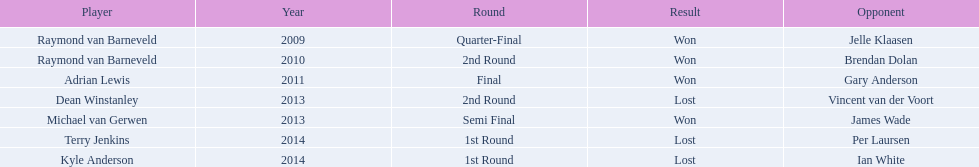Who claimed victory in 2014, terry jenkins or per laursen? Per Laursen. 